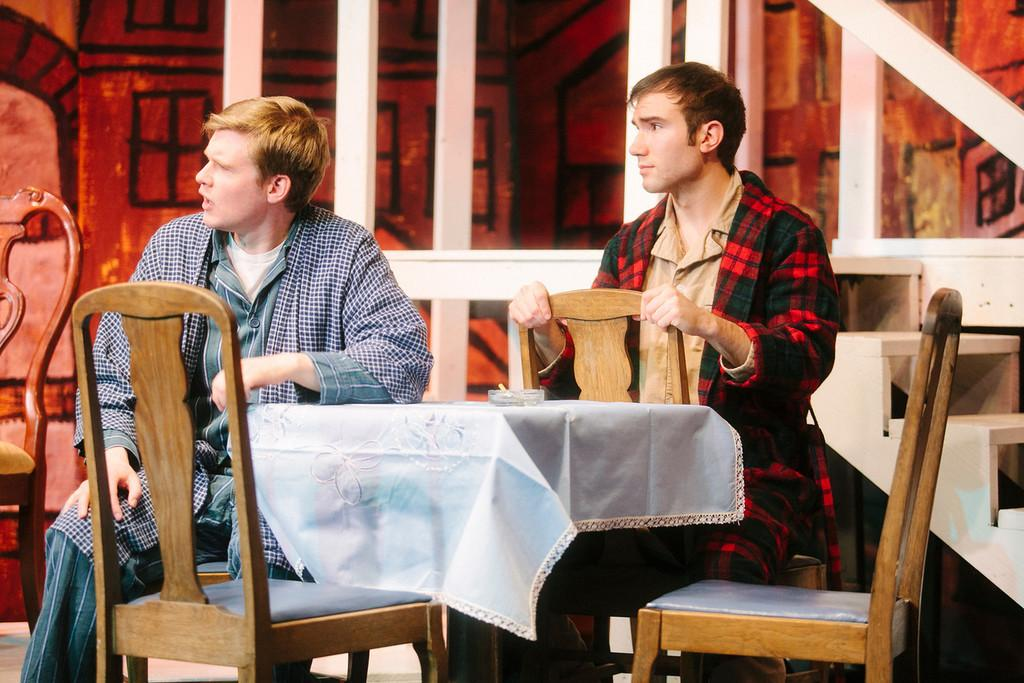Who is present in the image? There is a man in the image. What is the man doing in the image? The man is sitting on a chair. Where is the chair located in relation to the table? The chair is in front of a table. What can be seen on the table in the image? There is an object on the table, and it is covered with a white cloth. What historical event is being discussed by the women in the image? There are no women present in the image, and no historical event is being discussed. 